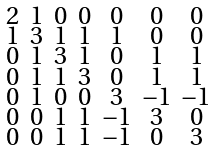Convert formula to latex. <formula><loc_0><loc_0><loc_500><loc_500>\begin{smallmatrix} 2 & 1 & 0 & 0 & 0 & 0 & 0 \\ 1 & 3 & 1 & 1 & 1 & 0 & 0 \\ 0 & 1 & 3 & 1 & 0 & 1 & 1 \\ 0 & 1 & 1 & 3 & 0 & 1 & 1 \\ 0 & 1 & 0 & 0 & 3 & - 1 & - 1 \\ 0 & 0 & 1 & 1 & - 1 & 3 & 0 \\ 0 & 0 & 1 & 1 & - 1 & 0 & 3 \end{smallmatrix}</formula> 